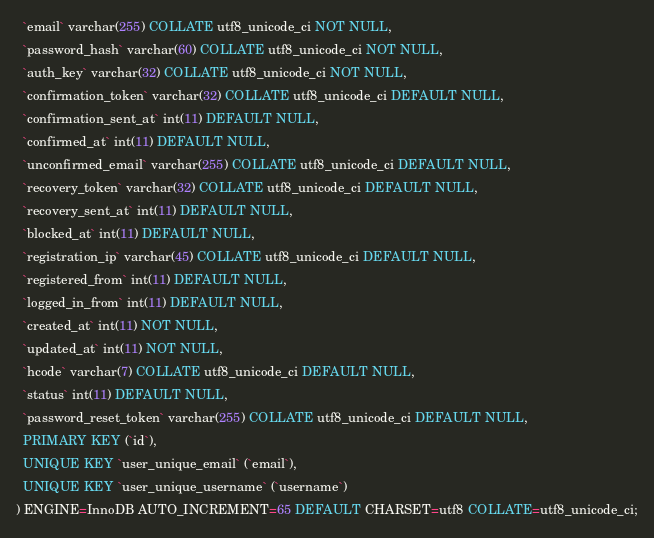<code> <loc_0><loc_0><loc_500><loc_500><_SQL_>  `email` varchar(255) COLLATE utf8_unicode_ci NOT NULL,
  `password_hash` varchar(60) COLLATE utf8_unicode_ci NOT NULL,
  `auth_key` varchar(32) COLLATE utf8_unicode_ci NOT NULL,
  `confirmation_token` varchar(32) COLLATE utf8_unicode_ci DEFAULT NULL,
  `confirmation_sent_at` int(11) DEFAULT NULL,
  `confirmed_at` int(11) DEFAULT NULL,
  `unconfirmed_email` varchar(255) COLLATE utf8_unicode_ci DEFAULT NULL,
  `recovery_token` varchar(32) COLLATE utf8_unicode_ci DEFAULT NULL,
  `recovery_sent_at` int(11) DEFAULT NULL,
  `blocked_at` int(11) DEFAULT NULL,
  `registration_ip` varchar(45) COLLATE utf8_unicode_ci DEFAULT NULL,
  `registered_from` int(11) DEFAULT NULL,
  `logged_in_from` int(11) DEFAULT NULL,
  `created_at` int(11) NOT NULL,
  `updated_at` int(11) NOT NULL,
  `hcode` varchar(7) COLLATE utf8_unicode_ci DEFAULT NULL,
  `status` int(11) DEFAULT NULL,
  `password_reset_token` varchar(255) COLLATE utf8_unicode_ci DEFAULT NULL,
  PRIMARY KEY (`id`),
  UNIQUE KEY `user_unique_email` (`email`),
  UNIQUE KEY `user_unique_username` (`username`)
) ENGINE=InnoDB AUTO_INCREMENT=65 DEFAULT CHARSET=utf8 COLLATE=utf8_unicode_ci;
</code> 